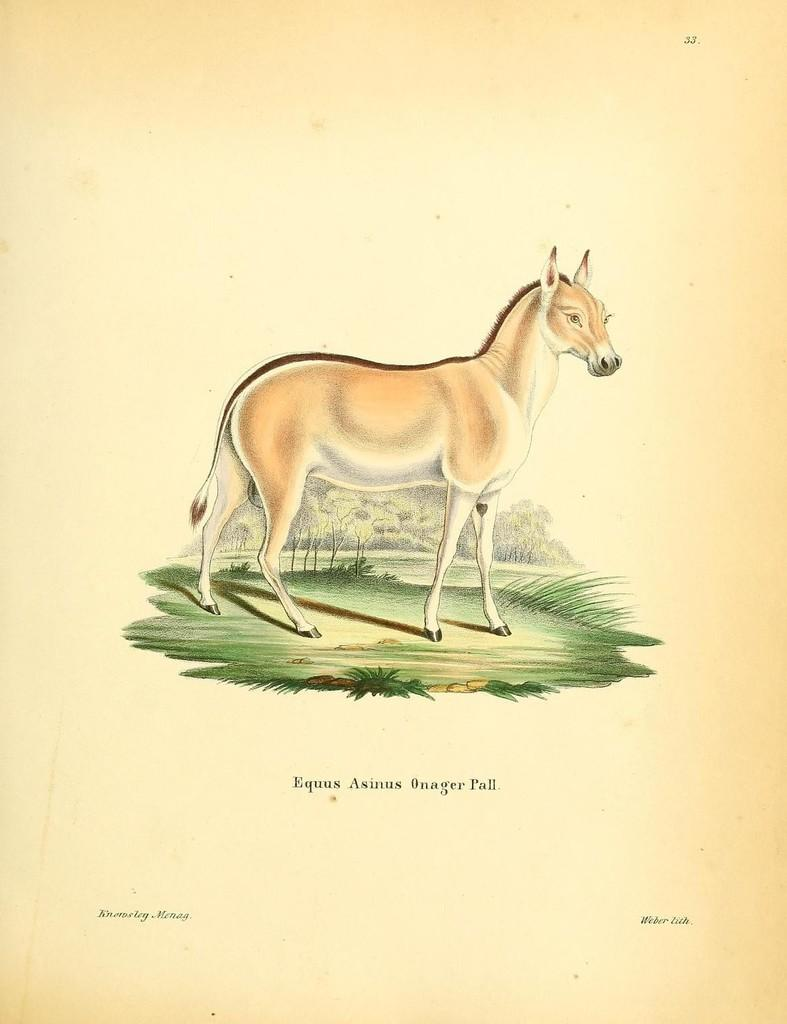What color is the background of the image? The background of the image is cream-colored. What is depicted in the painting within the image? There is a painting of an animal in the image. What is the animal doing in the painting? The animal is standing on the ground in the painting. What type of natural scenery can be seen in the background of the image? There are trees visible in the background of the image. What type of vegetable is being served as a meal in the image? There is no meal or vegetable present in the image; it features a painting of an animal with a cream-colored background and trees in the background. 